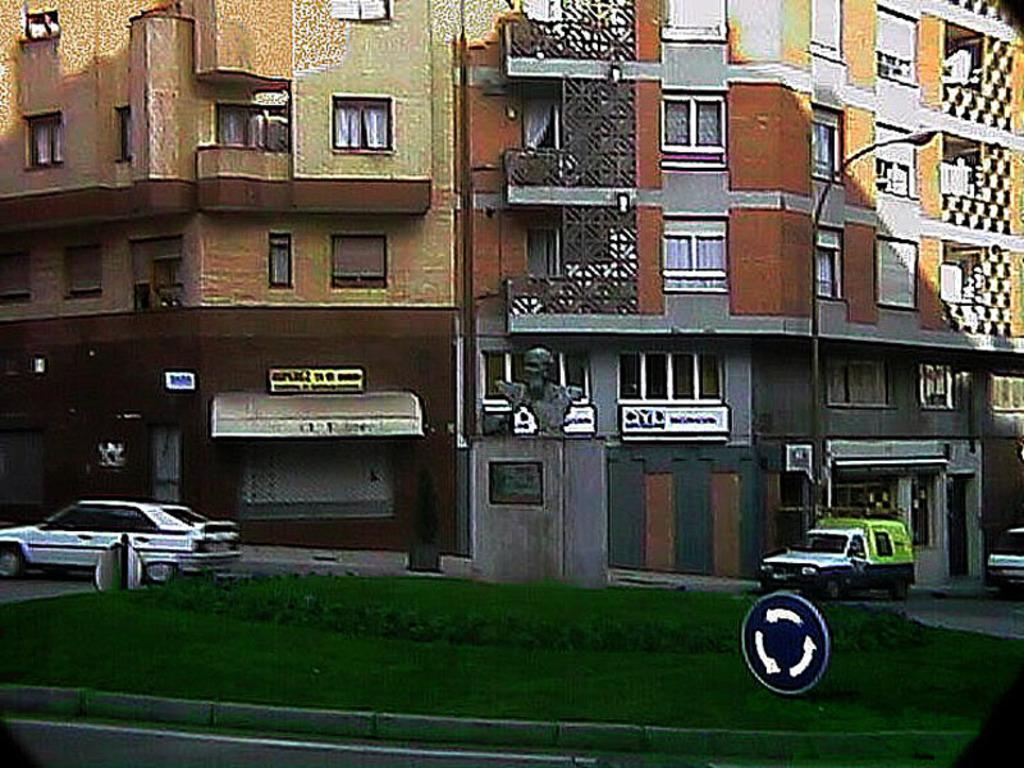How would you summarize this image in a sentence or two? In the picture I can see some buildings, in front we can see vehicles are moving and there is a sculpture around we can see the grass. 